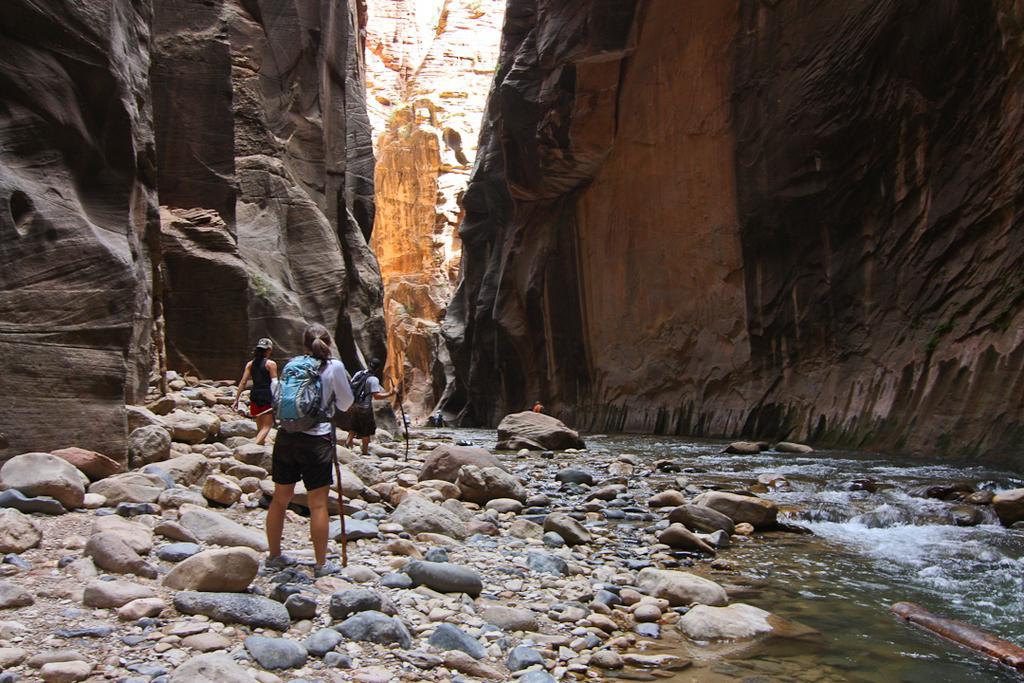Could you give a brief overview of what you see in this image? In this image we can see a few people. And we can see the stones, water. And on either side, we can see the rocks. 